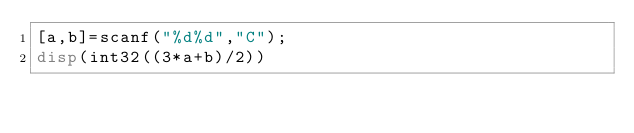Convert code to text. <code><loc_0><loc_0><loc_500><loc_500><_Octave_>[a,b]=scanf("%d%d","C");
disp(int32((3*a+b)/2))</code> 